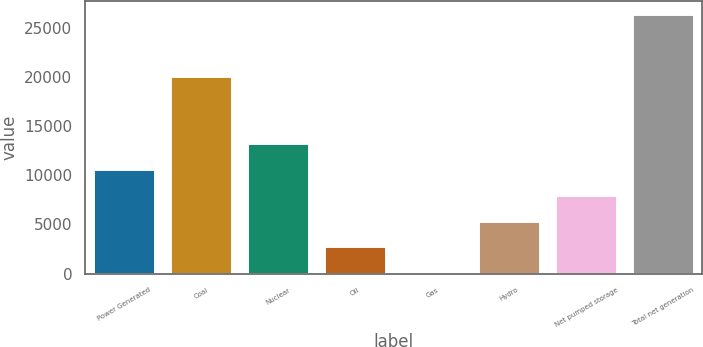Convert chart. <chart><loc_0><loc_0><loc_500><loc_500><bar_chart><fcel>Power Generated<fcel>Coal<fcel>Nuclear<fcel>Oil<fcel>Gas<fcel>Hydro<fcel>Net pumped storage<fcel>Total net generation<nl><fcel>10649.8<fcel>20091<fcel>13280<fcel>2759.2<fcel>129<fcel>5389.4<fcel>8019.6<fcel>26431<nl></chart> 